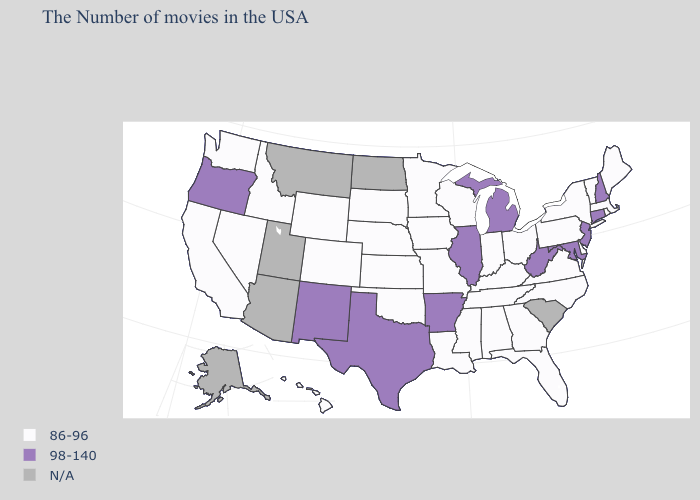What is the highest value in the USA?
Keep it brief. 98-140. What is the highest value in the USA?
Keep it brief. 98-140. Name the states that have a value in the range 98-140?
Write a very short answer. New Hampshire, Connecticut, New Jersey, Maryland, West Virginia, Michigan, Illinois, Arkansas, Texas, New Mexico, Oregon. Name the states that have a value in the range N/A?
Concise answer only. South Carolina, North Dakota, Utah, Montana, Arizona, Alaska. Which states have the lowest value in the USA?
Write a very short answer. Maine, Massachusetts, Rhode Island, Vermont, New York, Delaware, Pennsylvania, Virginia, North Carolina, Ohio, Florida, Georgia, Kentucky, Indiana, Alabama, Tennessee, Wisconsin, Mississippi, Louisiana, Missouri, Minnesota, Iowa, Kansas, Nebraska, Oklahoma, South Dakota, Wyoming, Colorado, Idaho, Nevada, California, Washington, Hawaii. What is the value of South Dakota?
Write a very short answer. 86-96. What is the highest value in the USA?
Give a very brief answer. 98-140. Name the states that have a value in the range N/A?
Concise answer only. South Carolina, North Dakota, Utah, Montana, Arizona, Alaska. Name the states that have a value in the range 86-96?
Quick response, please. Maine, Massachusetts, Rhode Island, Vermont, New York, Delaware, Pennsylvania, Virginia, North Carolina, Ohio, Florida, Georgia, Kentucky, Indiana, Alabama, Tennessee, Wisconsin, Mississippi, Louisiana, Missouri, Minnesota, Iowa, Kansas, Nebraska, Oklahoma, South Dakota, Wyoming, Colorado, Idaho, Nevada, California, Washington, Hawaii. What is the value of Kansas?
Short answer required. 86-96. What is the value of Missouri?
Answer briefly. 86-96. What is the lowest value in the USA?
Keep it brief. 86-96. Name the states that have a value in the range 98-140?
Write a very short answer. New Hampshire, Connecticut, New Jersey, Maryland, West Virginia, Michigan, Illinois, Arkansas, Texas, New Mexico, Oregon. Does New Jersey have the highest value in the USA?
Keep it brief. Yes. Name the states that have a value in the range N/A?
Short answer required. South Carolina, North Dakota, Utah, Montana, Arizona, Alaska. 